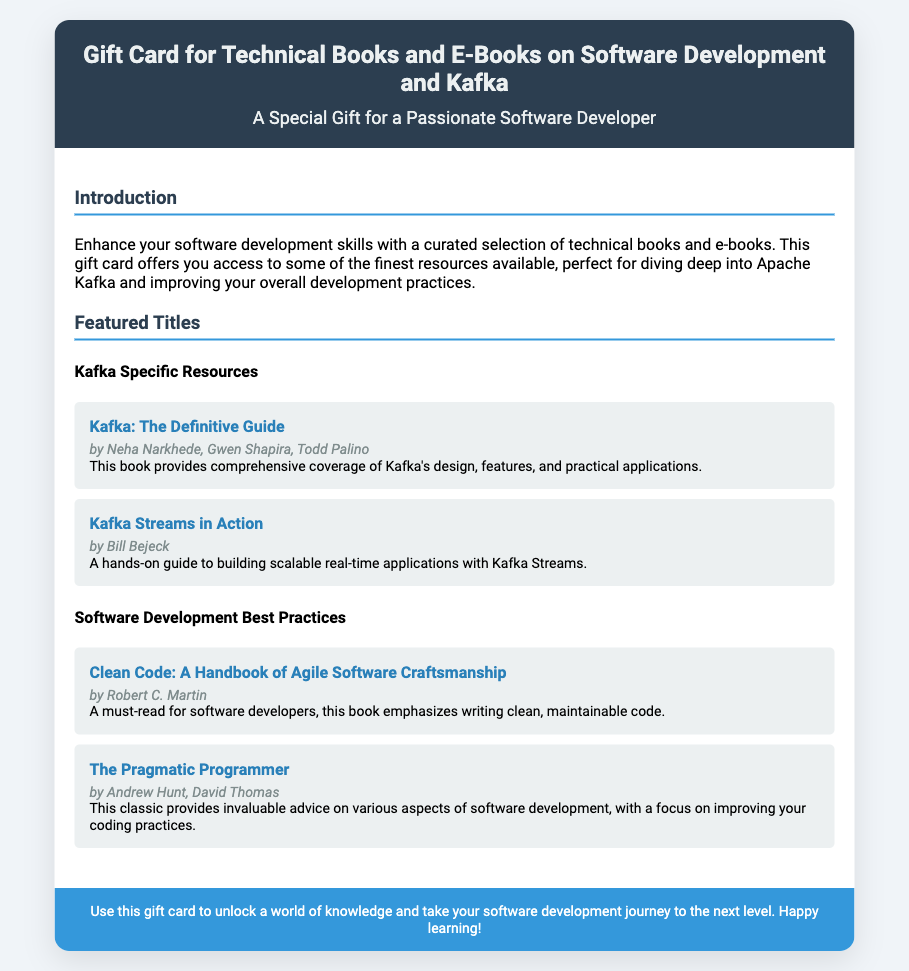What is the title of the gift card? The title of the gift card is prominently displayed in the header section of the document.
Answer: Gift Card for Technical Books and E-Books on Software Development and Kafka Who is the author of "Kafka: The Definitive Guide"? The author names for each book are provided below their titles in the document.
Answer: Neha Narkhede, Gwen Shapira, Todd Palino How many subtitles are listed under "Featured Titles"? The document contains two subsections under the "Featured Titles" section.
Answer: Two What is emphasized in "Clean Code"? The document specifies the focus of each book, indicating the main themes or advice offered.
Answer: Writing clean, maintainable code What is the overall purpose of the gift card? The purpose of the gift card is summarised in the introduction section of the document.
Answer: Enhance your software development skills What type of resources does the gift card provide access to? The introduction specifies the type of resources offered by the gift card.
Answer: Technical books and e-books How many featured Kafka specific resources are mentioned? The number of Kafka specific resources is identifiable in their section within the document.
Answer: Two What is the color of the header background? The color details of the header section are included in the style specifications.
Answer: #2c3e50 What should recipients do with the gift card? The footer gives direction on how to utilize the gift card effectively.
Answer: Unlock a world of knowledge 